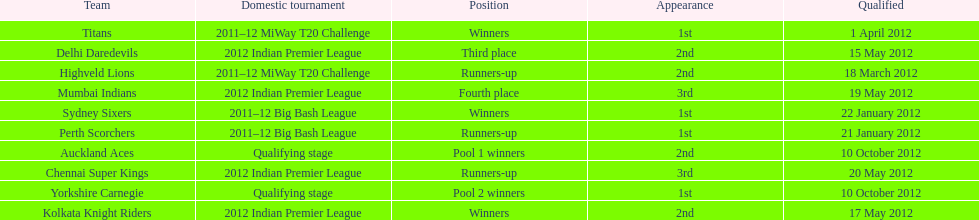Which groups were the final ones to make it through the qualification process? Auckland Aces, Yorkshire Carnegie. 